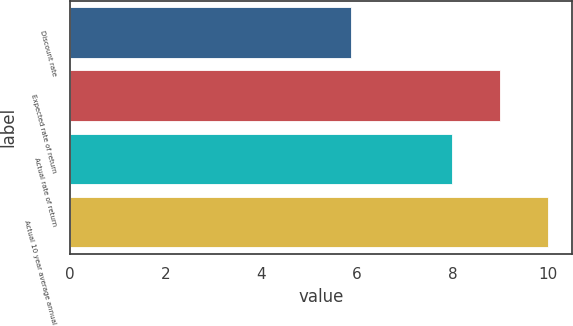Convert chart to OTSL. <chart><loc_0><loc_0><loc_500><loc_500><bar_chart><fcel>Discount rate<fcel>Expected rate of return<fcel>Actual rate of return<fcel>Actual 10 year average annual<nl><fcel>5.88<fcel>9<fcel>8<fcel>10<nl></chart> 